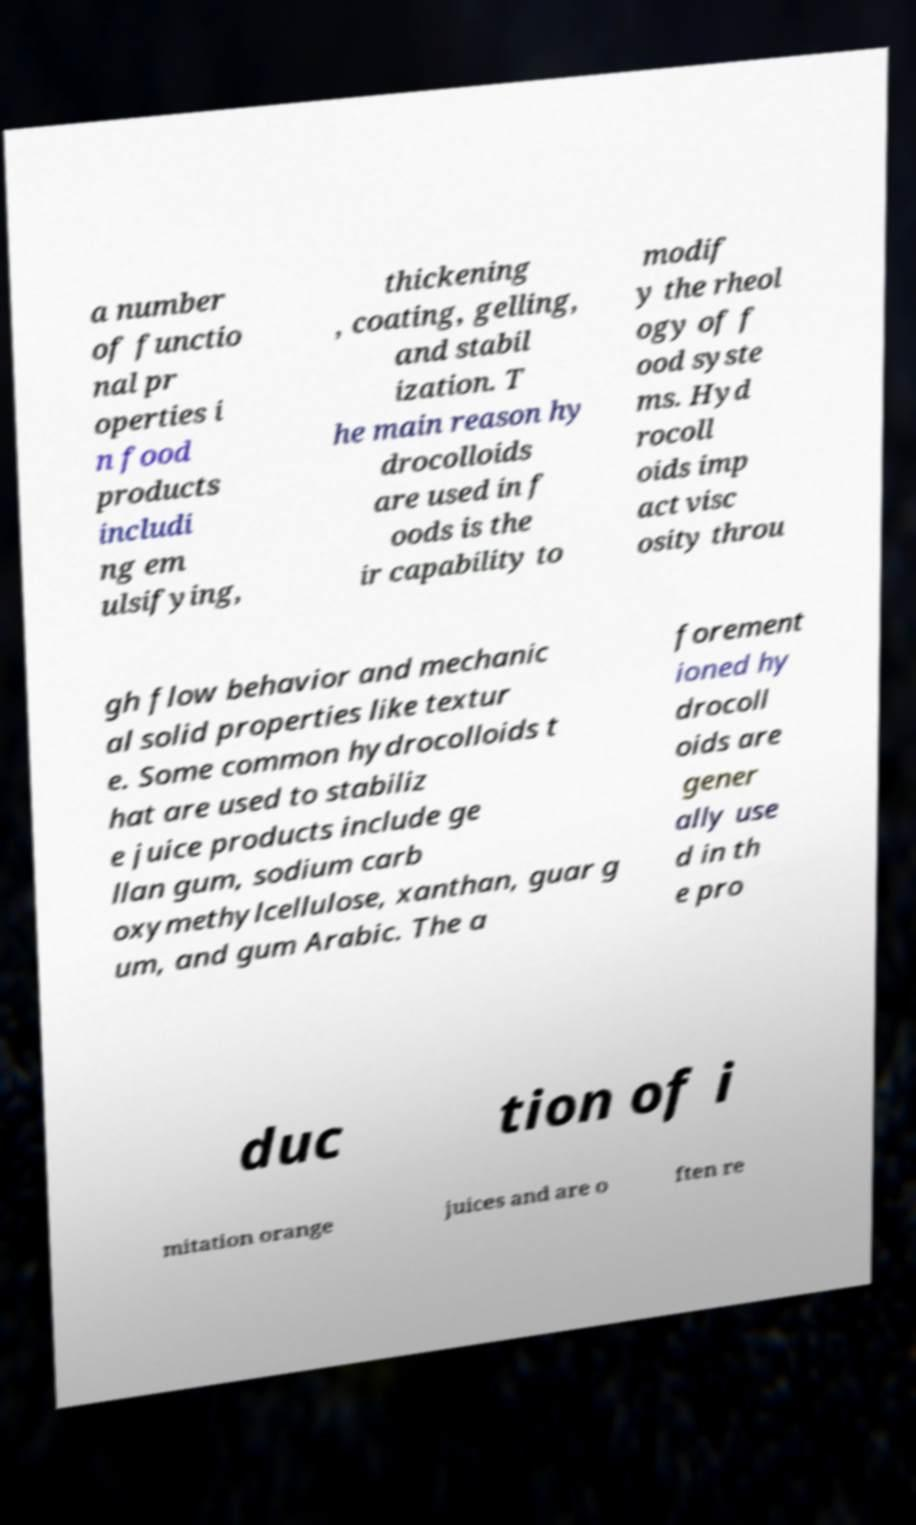Please identify and transcribe the text found in this image. a number of functio nal pr operties i n food products includi ng em ulsifying, thickening , coating, gelling, and stabil ization. T he main reason hy drocolloids are used in f oods is the ir capability to modif y the rheol ogy of f ood syste ms. Hyd rocoll oids imp act visc osity throu gh flow behavior and mechanic al solid properties like textur e. Some common hydrocolloids t hat are used to stabiliz e juice products include ge llan gum, sodium carb oxymethylcellulose, xanthan, guar g um, and gum Arabic. The a forement ioned hy drocoll oids are gener ally use d in th e pro duc tion of i mitation orange juices and are o ften re 